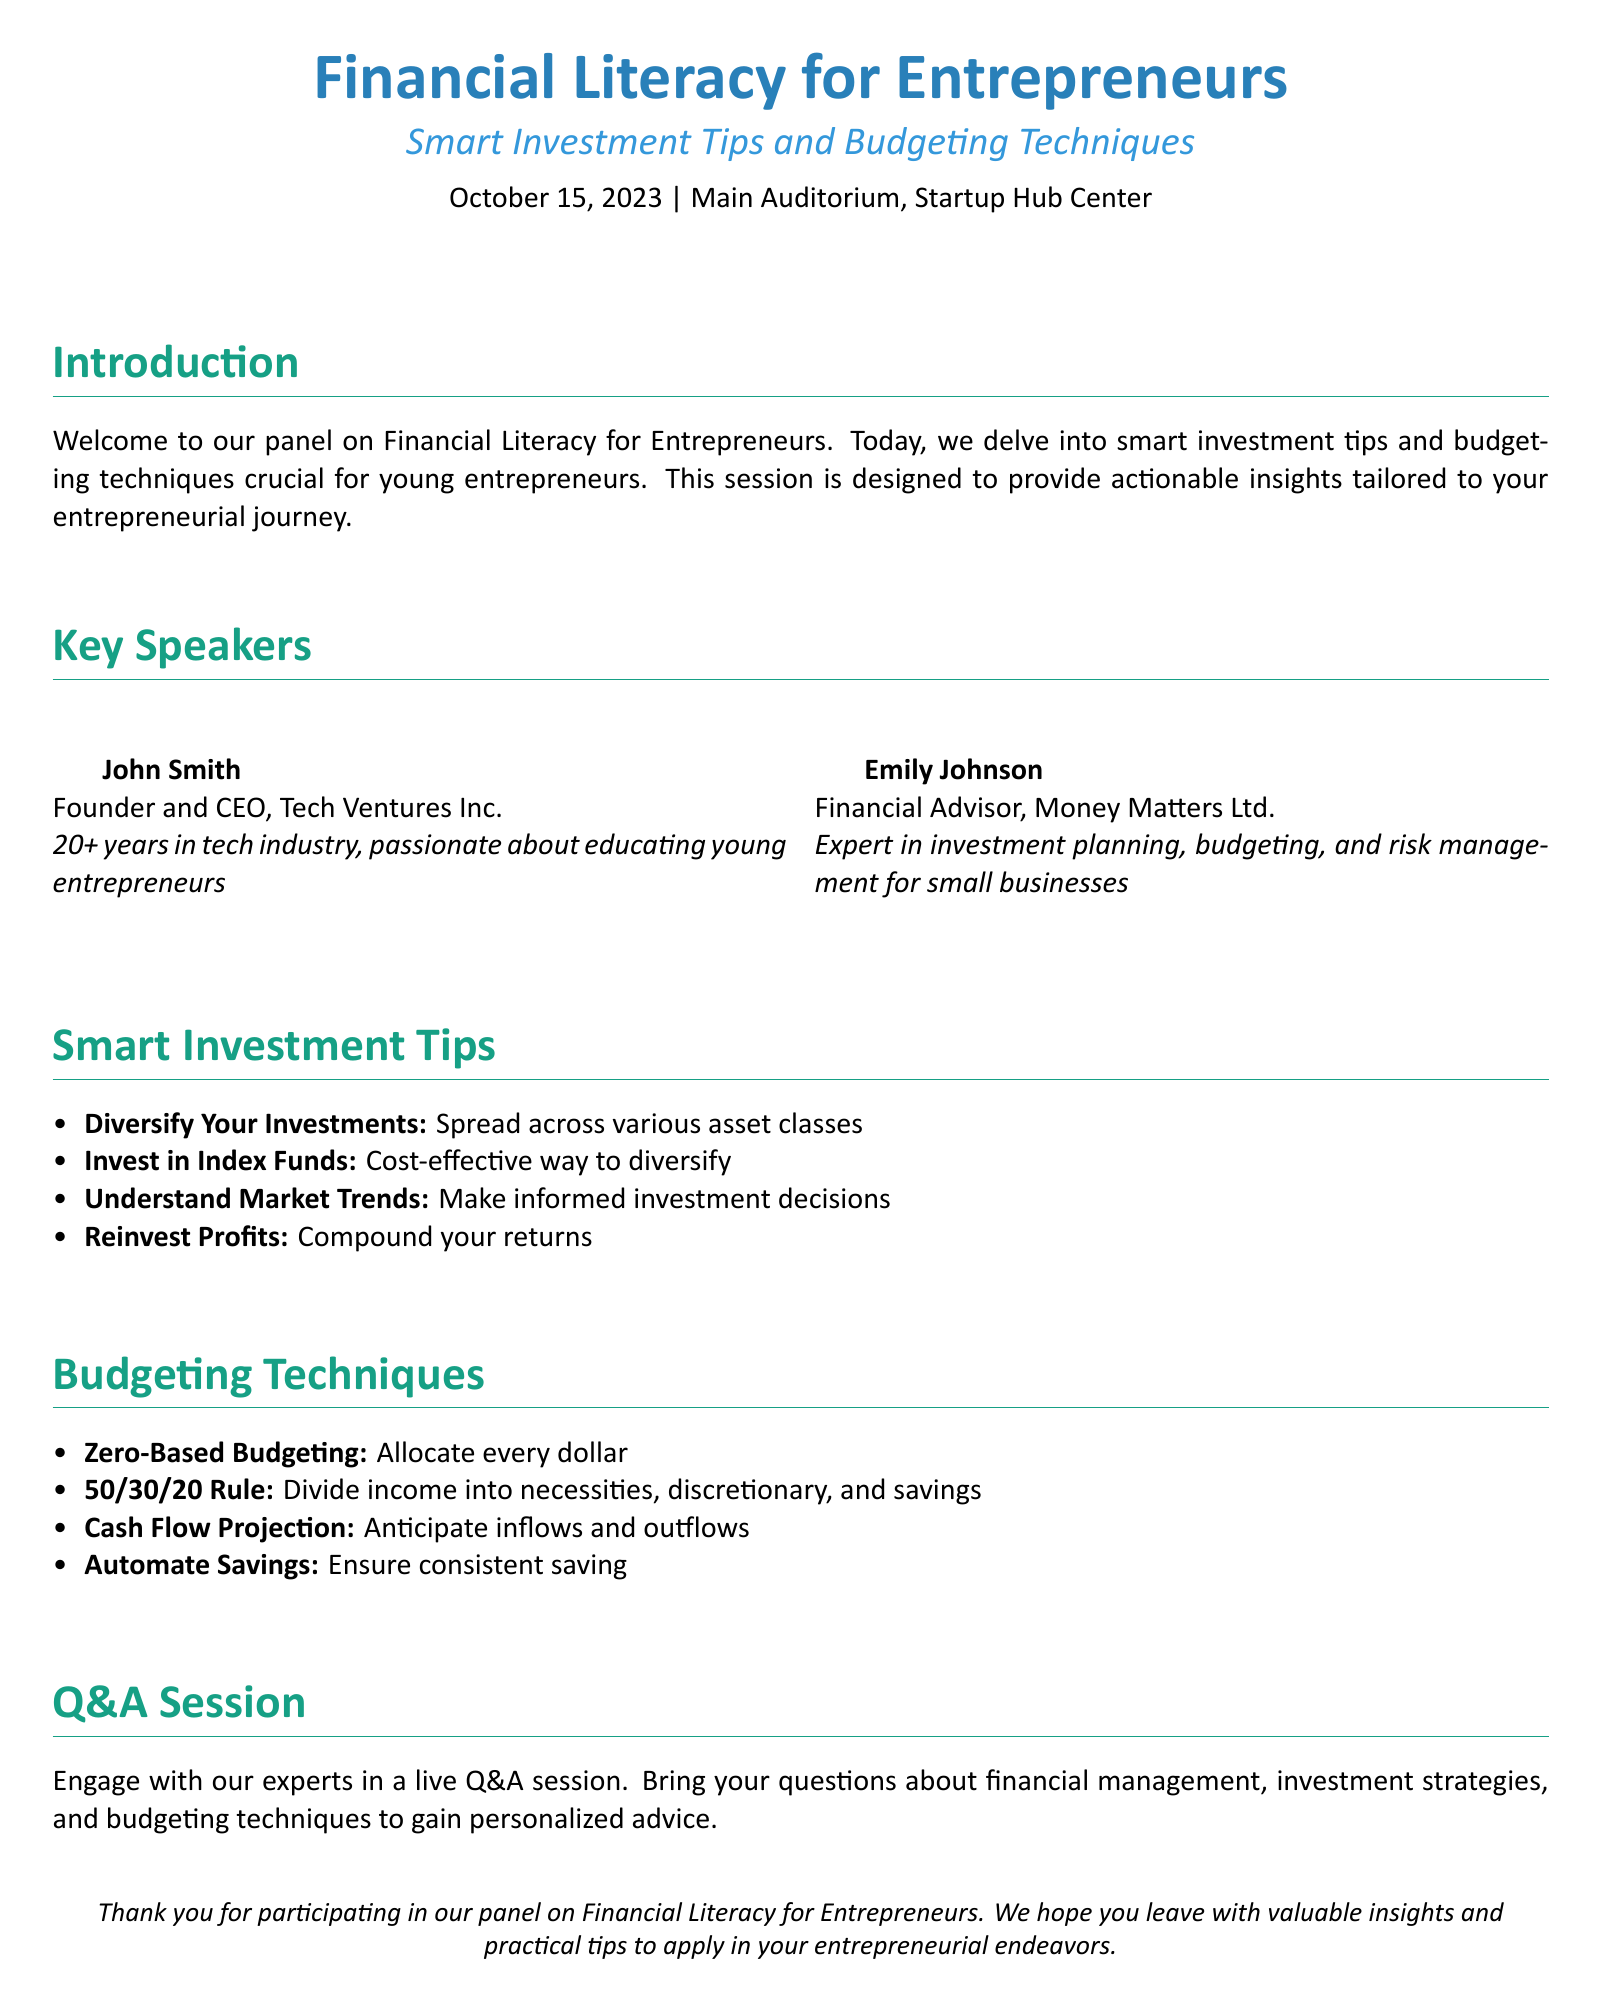What is the date of the event? The date of the event is mentioned in the document as October 15, 2023.
Answer: October 15, 2023 Who is the CEO of Tech Ventures Inc? The document lists John Smith as the Founder and CEO of Tech Ventures Inc.
Answer: John Smith What budgeting method is suggested for allocating every dollar? The document specifies the zero-based budgeting technique for this purpose.
Answer: Zero-Based Budgeting What is the main theme of the panel discussion? The theme revolves around Financial Literacy for Entrepreneurs, focusing on smart investment tips and budgeting techniques.
Answer: Financial Literacy for Entrepreneurs What is the 50/30/20 Rule? The document outlines this rule as dividing income into necessities, discretionary spending, and savings.
Answer: Divide income into necessities, discretionary, and savings Who is an expert in investment planning mentioned in the document? Emily Johnson is identified as the financial advisor and expert in investment planning in the document.
Answer: Emily Johnson What technique is recommended for ensuring consistent saving? The document advises automating savings as a technique for consistent saving.
Answer: Automate Savings What type of investments does the document encourage? The document encourages diversifying investments across various asset classes.
Answer: Diversify Your Investments What is one form of investment mentioned in the smart investment tips? The document mentions investing in index funds as a cost-effective way to diversify.
Answer: Index Funds 